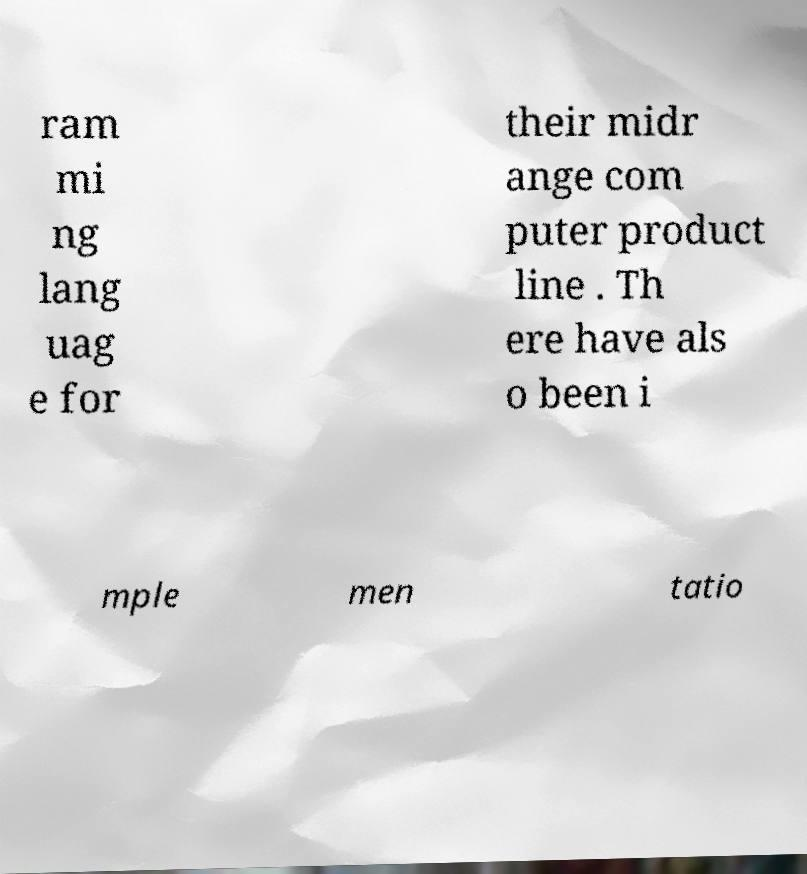For documentation purposes, I need the text within this image transcribed. Could you provide that? ram mi ng lang uag e for their midr ange com puter product line . Th ere have als o been i mple men tatio 